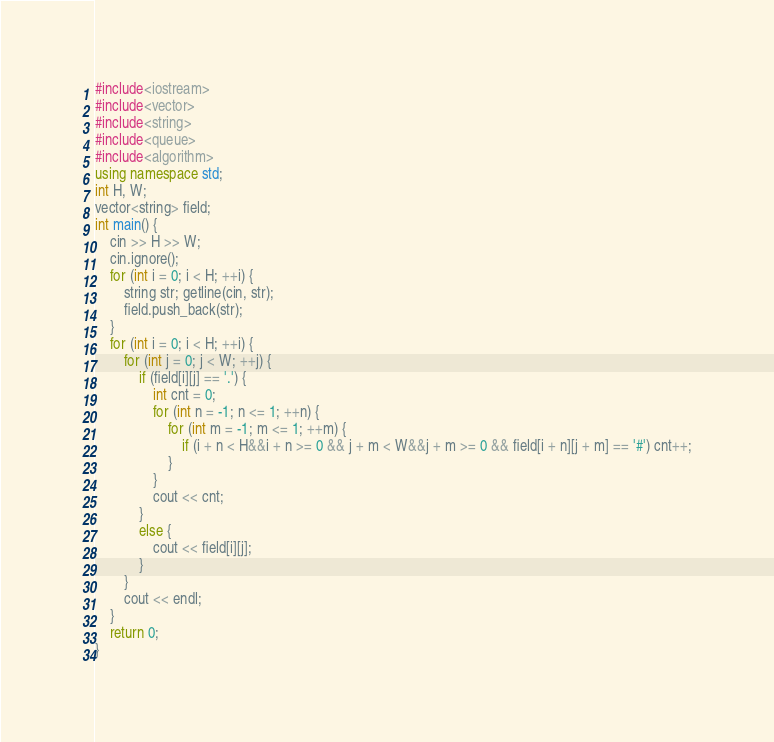<code> <loc_0><loc_0><loc_500><loc_500><_C++_>#include<iostream>
#include<vector>
#include<string>
#include<queue>
#include<algorithm>
using namespace std;
int H, W;
vector<string> field;
int main() {
	cin >> H >> W;
	cin.ignore();
	for (int i = 0; i < H; ++i) {
		string str; getline(cin, str);
		field.push_back(str);
	}
	for (int i = 0; i < H; ++i) {
		for (int j = 0; j < W; ++j) {
			if (field[i][j] == '.') {
				int cnt = 0;
				for (int n = -1; n <= 1; ++n) {
					for (int m = -1; m <= 1; ++m) {
						if (i + n < H&&i + n >= 0 && j + m < W&&j + m >= 0 && field[i + n][j + m] == '#') cnt++;
					}
				}
				cout << cnt;
			}
			else {
				cout << field[i][j];
			}
		}
		cout << endl;
	}
	return 0;
}</code> 